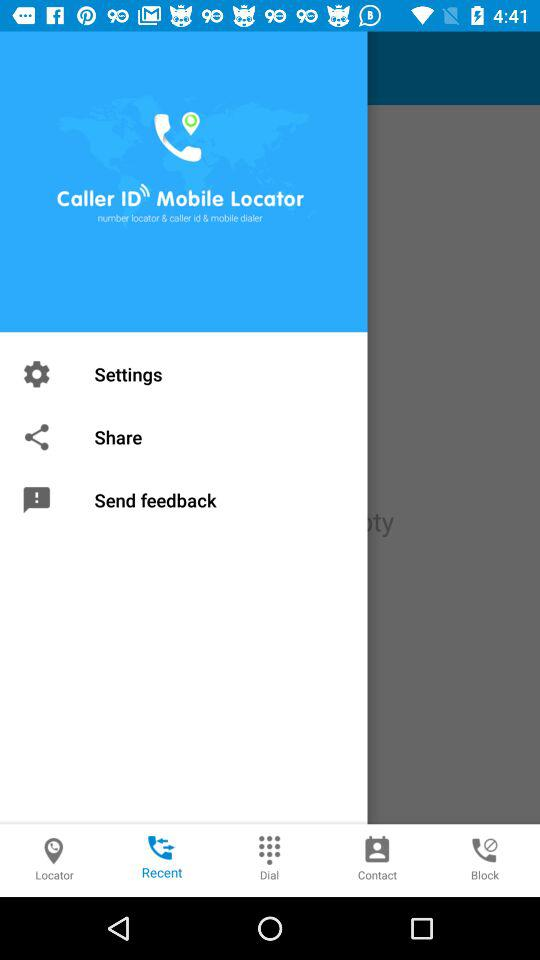What is the application name? The name of the application is "Caller ID Mobile Locator". 